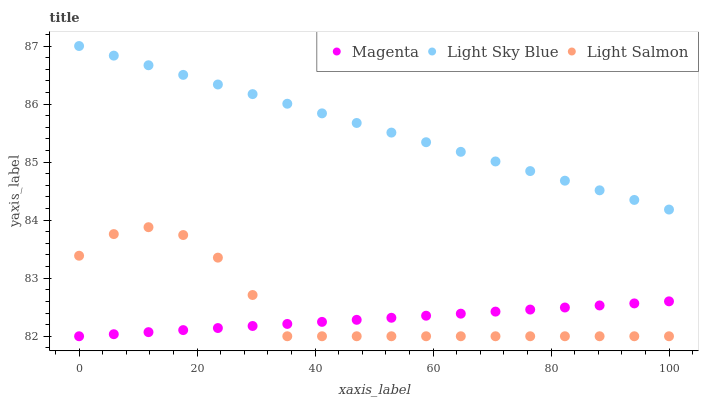Does Magenta have the minimum area under the curve?
Answer yes or no. Yes. Does Light Sky Blue have the maximum area under the curve?
Answer yes or no. Yes. Does Light Salmon have the minimum area under the curve?
Answer yes or no. No. Does Light Salmon have the maximum area under the curve?
Answer yes or no. No. Is Light Sky Blue the smoothest?
Answer yes or no. Yes. Is Light Salmon the roughest?
Answer yes or no. Yes. Is Light Salmon the smoothest?
Answer yes or no. No. Is Light Sky Blue the roughest?
Answer yes or no. No. Does Magenta have the lowest value?
Answer yes or no. Yes. Does Light Sky Blue have the lowest value?
Answer yes or no. No. Does Light Sky Blue have the highest value?
Answer yes or no. Yes. Does Light Salmon have the highest value?
Answer yes or no. No. Is Light Salmon less than Light Sky Blue?
Answer yes or no. Yes. Is Light Sky Blue greater than Magenta?
Answer yes or no. Yes. Does Magenta intersect Light Salmon?
Answer yes or no. Yes. Is Magenta less than Light Salmon?
Answer yes or no. No. Is Magenta greater than Light Salmon?
Answer yes or no. No. Does Light Salmon intersect Light Sky Blue?
Answer yes or no. No. 